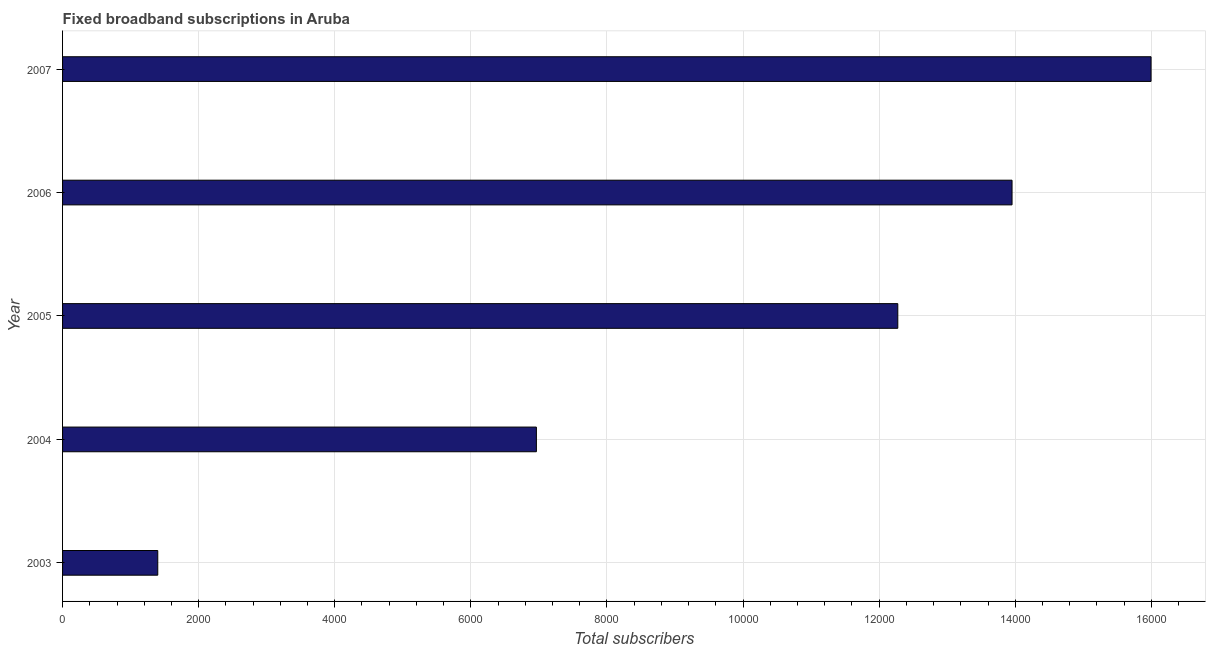Does the graph contain grids?
Ensure brevity in your answer.  Yes. What is the title of the graph?
Make the answer very short. Fixed broadband subscriptions in Aruba. What is the label or title of the X-axis?
Your answer should be compact. Total subscribers. What is the total number of fixed broadband subscriptions in 2006?
Your response must be concise. 1.40e+04. Across all years, what is the maximum total number of fixed broadband subscriptions?
Keep it short and to the point. 1.60e+04. Across all years, what is the minimum total number of fixed broadband subscriptions?
Make the answer very short. 1399. In which year was the total number of fixed broadband subscriptions maximum?
Provide a succinct answer. 2007. In which year was the total number of fixed broadband subscriptions minimum?
Ensure brevity in your answer.  2003. What is the sum of the total number of fixed broadband subscriptions?
Your answer should be very brief. 5.06e+04. What is the difference between the total number of fixed broadband subscriptions in 2003 and 2007?
Offer a terse response. -1.46e+04. What is the average total number of fixed broadband subscriptions per year?
Provide a short and direct response. 1.01e+04. What is the median total number of fixed broadband subscriptions?
Your answer should be compact. 1.23e+04. In how many years, is the total number of fixed broadband subscriptions greater than 5200 ?
Keep it short and to the point. 4. What is the ratio of the total number of fixed broadband subscriptions in 2003 to that in 2006?
Offer a terse response. 0.1. Is the difference between the total number of fixed broadband subscriptions in 2003 and 2007 greater than the difference between any two years?
Offer a very short reply. Yes. What is the difference between the highest and the second highest total number of fixed broadband subscriptions?
Your answer should be compact. 2043. What is the difference between the highest and the lowest total number of fixed broadband subscriptions?
Offer a very short reply. 1.46e+04. In how many years, is the total number of fixed broadband subscriptions greater than the average total number of fixed broadband subscriptions taken over all years?
Give a very brief answer. 3. Are all the bars in the graph horizontal?
Make the answer very short. Yes. What is the difference between two consecutive major ticks on the X-axis?
Provide a short and direct response. 2000. What is the Total subscribers in 2003?
Your answer should be compact. 1399. What is the Total subscribers in 2004?
Your answer should be very brief. 6963. What is the Total subscribers in 2005?
Your response must be concise. 1.23e+04. What is the Total subscribers of 2006?
Provide a short and direct response. 1.40e+04. What is the Total subscribers of 2007?
Your answer should be compact. 1.60e+04. What is the difference between the Total subscribers in 2003 and 2004?
Your answer should be compact. -5564. What is the difference between the Total subscribers in 2003 and 2005?
Offer a terse response. -1.09e+04. What is the difference between the Total subscribers in 2003 and 2006?
Ensure brevity in your answer.  -1.26e+04. What is the difference between the Total subscribers in 2003 and 2007?
Offer a very short reply. -1.46e+04. What is the difference between the Total subscribers in 2004 and 2005?
Give a very brief answer. -5311. What is the difference between the Total subscribers in 2004 and 2006?
Provide a short and direct response. -6990. What is the difference between the Total subscribers in 2004 and 2007?
Provide a short and direct response. -9033. What is the difference between the Total subscribers in 2005 and 2006?
Offer a terse response. -1679. What is the difference between the Total subscribers in 2005 and 2007?
Provide a short and direct response. -3722. What is the difference between the Total subscribers in 2006 and 2007?
Keep it short and to the point. -2043. What is the ratio of the Total subscribers in 2003 to that in 2004?
Your answer should be very brief. 0.2. What is the ratio of the Total subscribers in 2003 to that in 2005?
Keep it short and to the point. 0.11. What is the ratio of the Total subscribers in 2003 to that in 2007?
Make the answer very short. 0.09. What is the ratio of the Total subscribers in 2004 to that in 2005?
Your response must be concise. 0.57. What is the ratio of the Total subscribers in 2004 to that in 2006?
Offer a terse response. 0.5. What is the ratio of the Total subscribers in 2004 to that in 2007?
Ensure brevity in your answer.  0.43. What is the ratio of the Total subscribers in 2005 to that in 2007?
Make the answer very short. 0.77. What is the ratio of the Total subscribers in 2006 to that in 2007?
Offer a terse response. 0.87. 